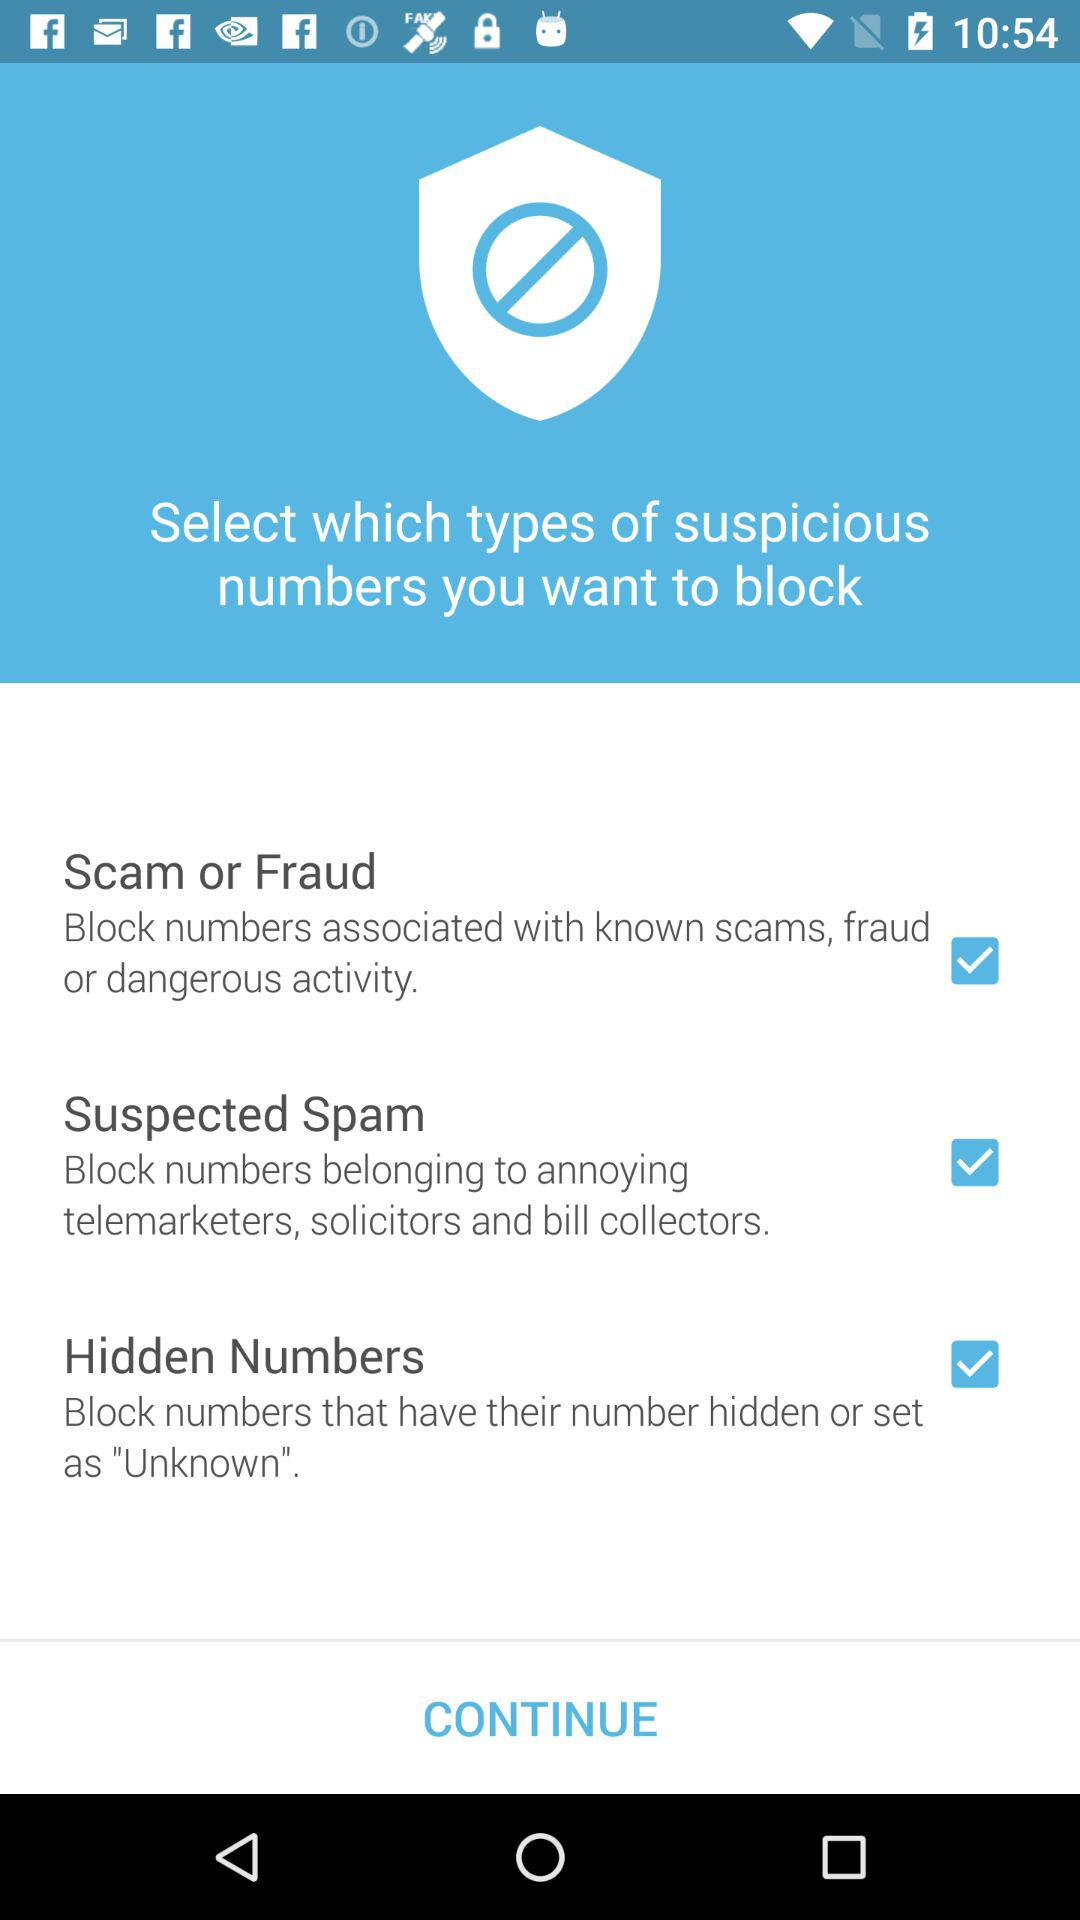What is the status of the "Suspected Spam"? The status of "Suspected Spam" is "on". 